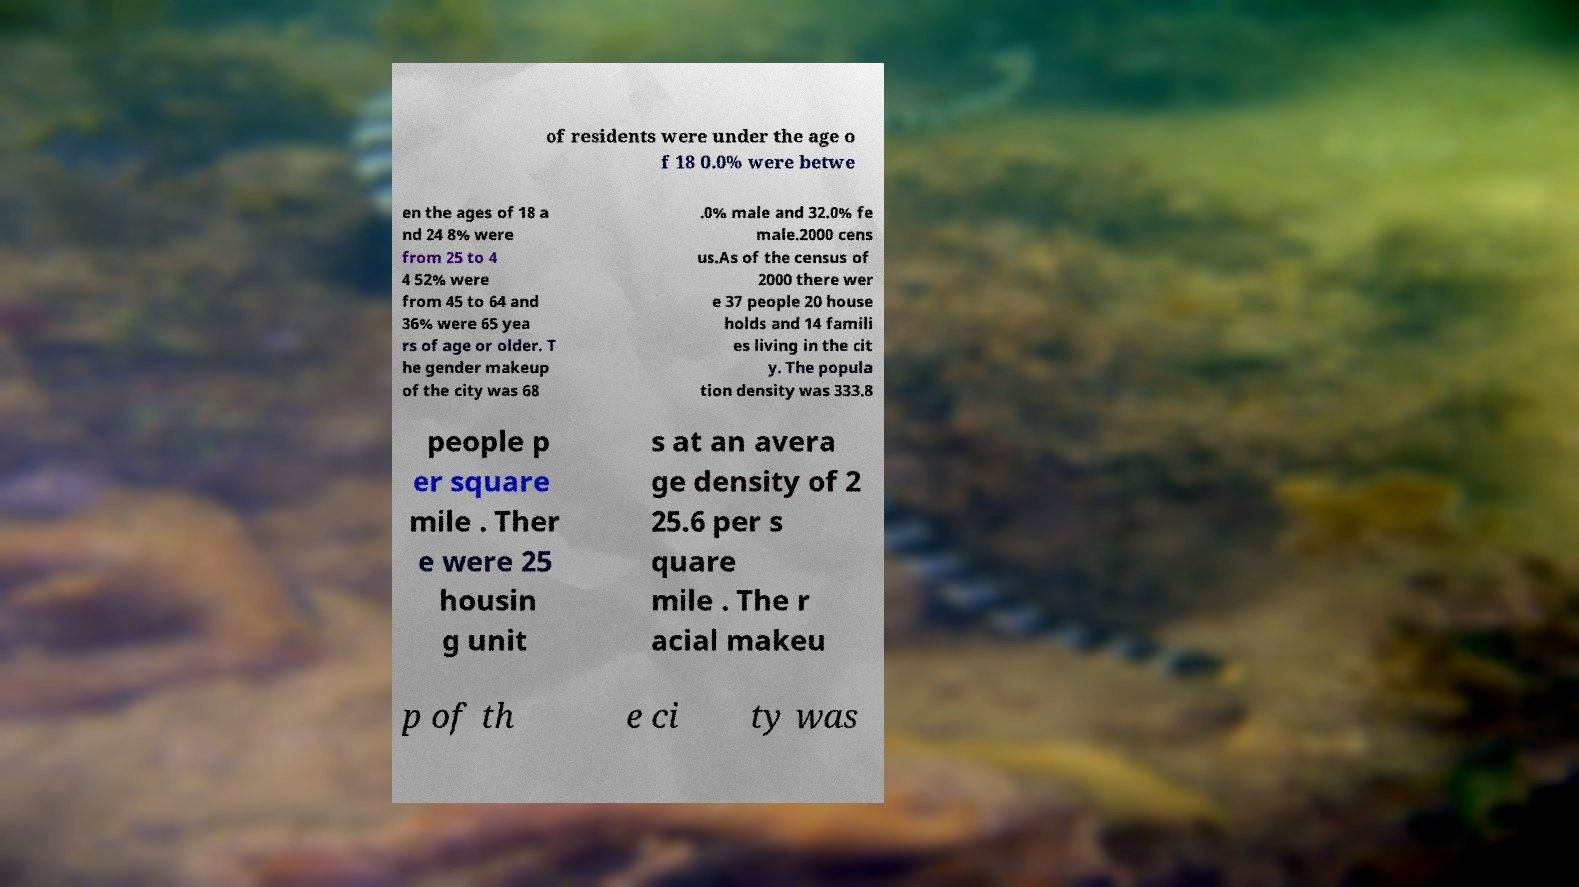Can you read and provide the text displayed in the image?This photo seems to have some interesting text. Can you extract and type it out for me? of residents were under the age o f 18 0.0% were betwe en the ages of 18 a nd 24 8% were from 25 to 4 4 52% were from 45 to 64 and 36% were 65 yea rs of age or older. T he gender makeup of the city was 68 .0% male and 32.0% fe male.2000 cens us.As of the census of 2000 there wer e 37 people 20 house holds and 14 famili es living in the cit y. The popula tion density was 333.8 people p er square mile . Ther e were 25 housin g unit s at an avera ge density of 2 25.6 per s quare mile . The r acial makeu p of th e ci ty was 